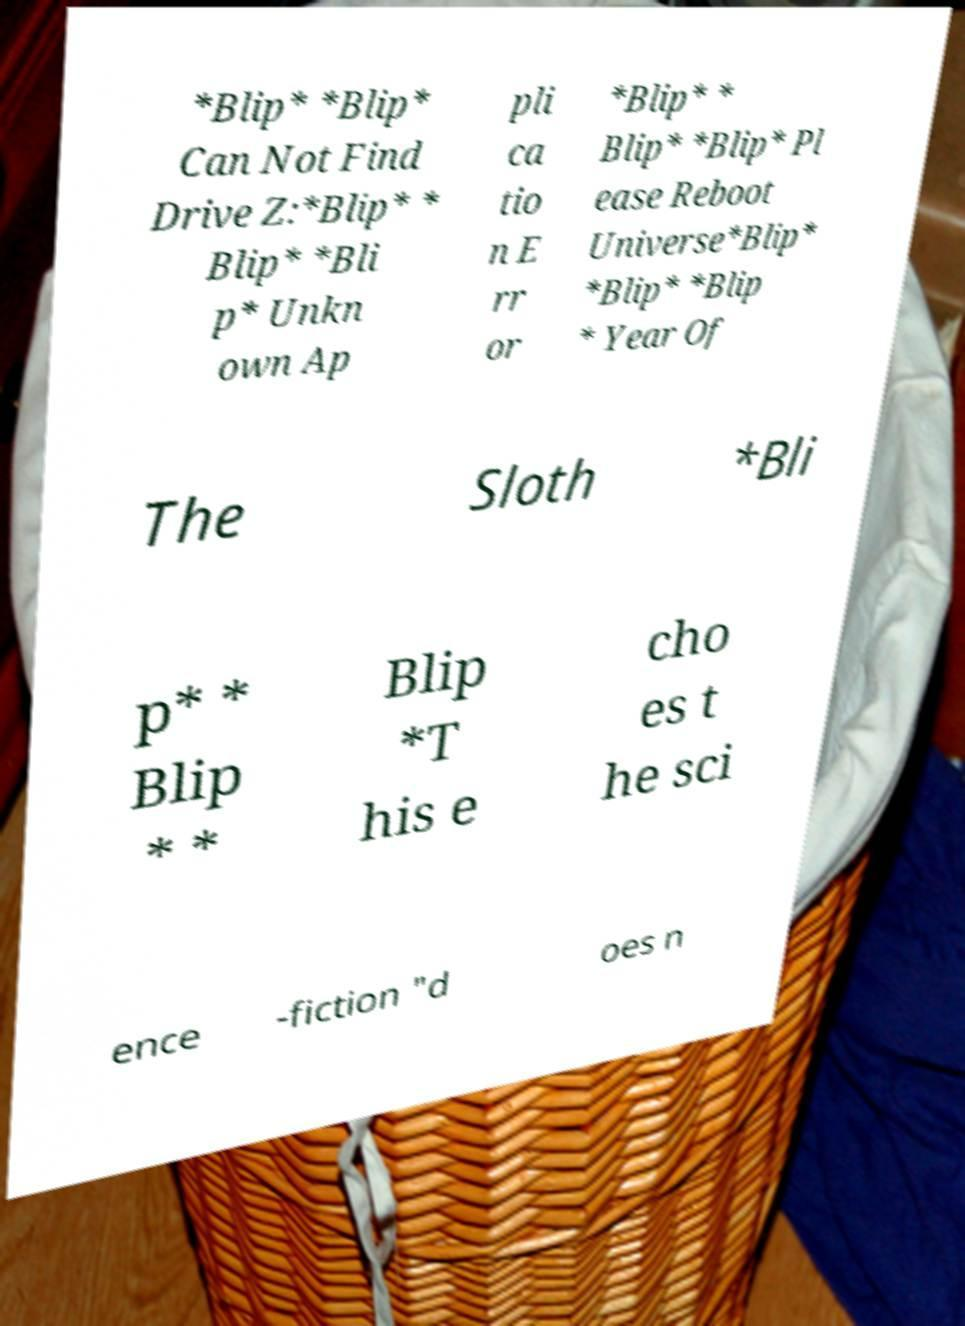Can you accurately transcribe the text from the provided image for me? *Blip* *Blip* Can Not Find Drive Z:*Blip* * Blip* *Bli p* Unkn own Ap pli ca tio n E rr or *Blip* * Blip* *Blip* Pl ease Reboot Universe*Blip* *Blip* *Blip * Year Of The Sloth *Bli p* * Blip * * Blip *T his e cho es t he sci ence -fiction "d oes n 